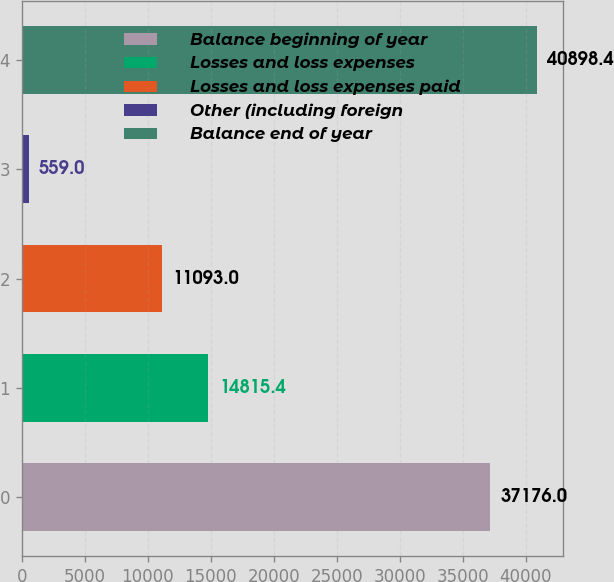<chart> <loc_0><loc_0><loc_500><loc_500><bar_chart><fcel>Balance beginning of year<fcel>Losses and loss expenses<fcel>Losses and loss expenses paid<fcel>Other (including foreign<fcel>Balance end of year<nl><fcel>37176<fcel>14815.4<fcel>11093<fcel>559<fcel>40898.4<nl></chart> 